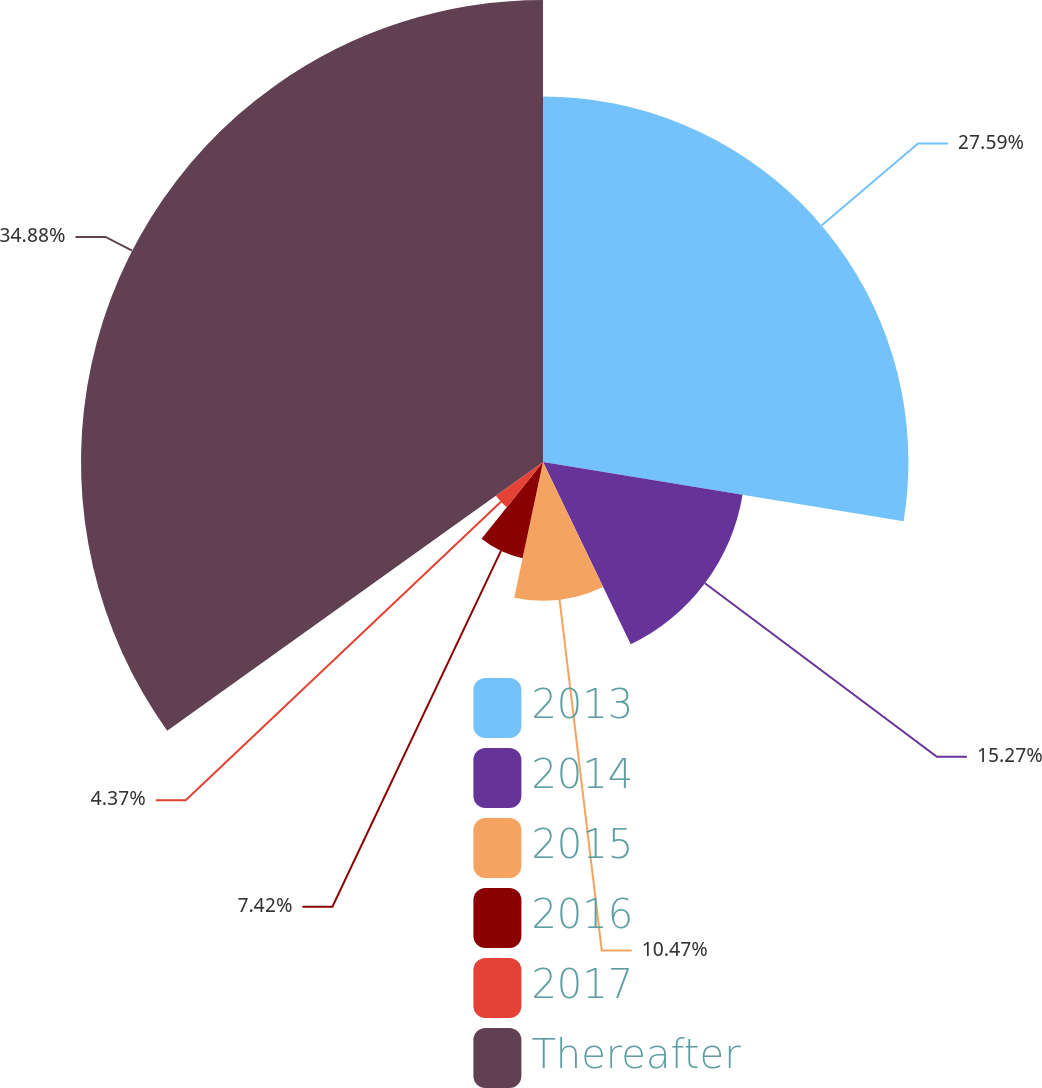Convert chart. <chart><loc_0><loc_0><loc_500><loc_500><pie_chart><fcel>2013<fcel>2014<fcel>2015<fcel>2016<fcel>2017<fcel>Thereafter<nl><fcel>27.59%<fcel>15.27%<fcel>10.47%<fcel>7.42%<fcel>4.37%<fcel>34.88%<nl></chart> 